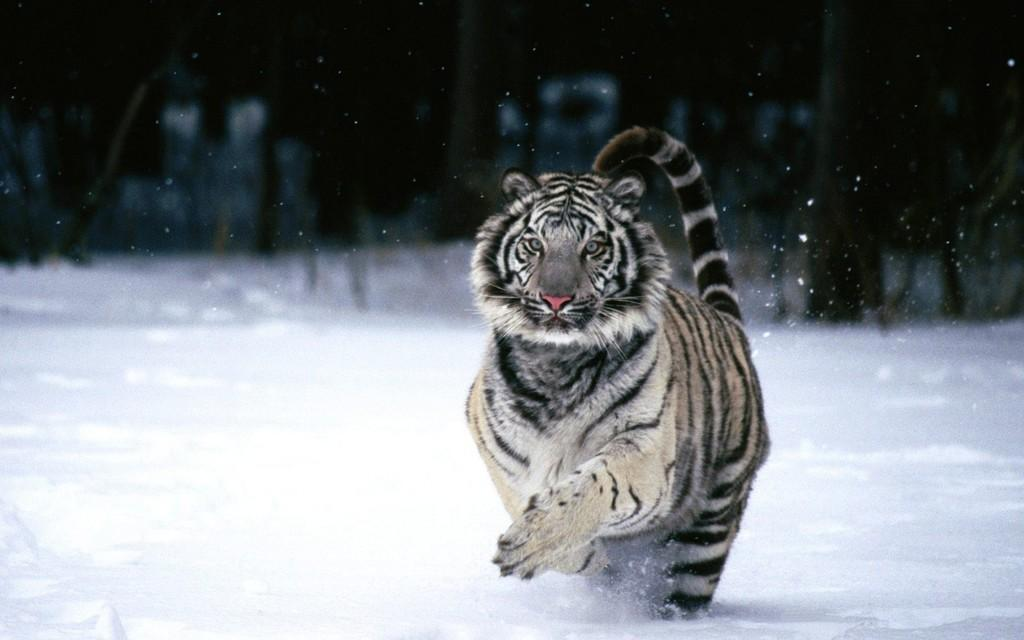What animal is the main subject of the image? There is a tiger in the image. What is the tiger standing on in the image? The tiger is on a snowy surface. How would you describe the background of the image? The background of the image is dark. Can you hear the tiger's roar in the image? There is no sound in the image, so it is not possible to hear the tiger's roar. 